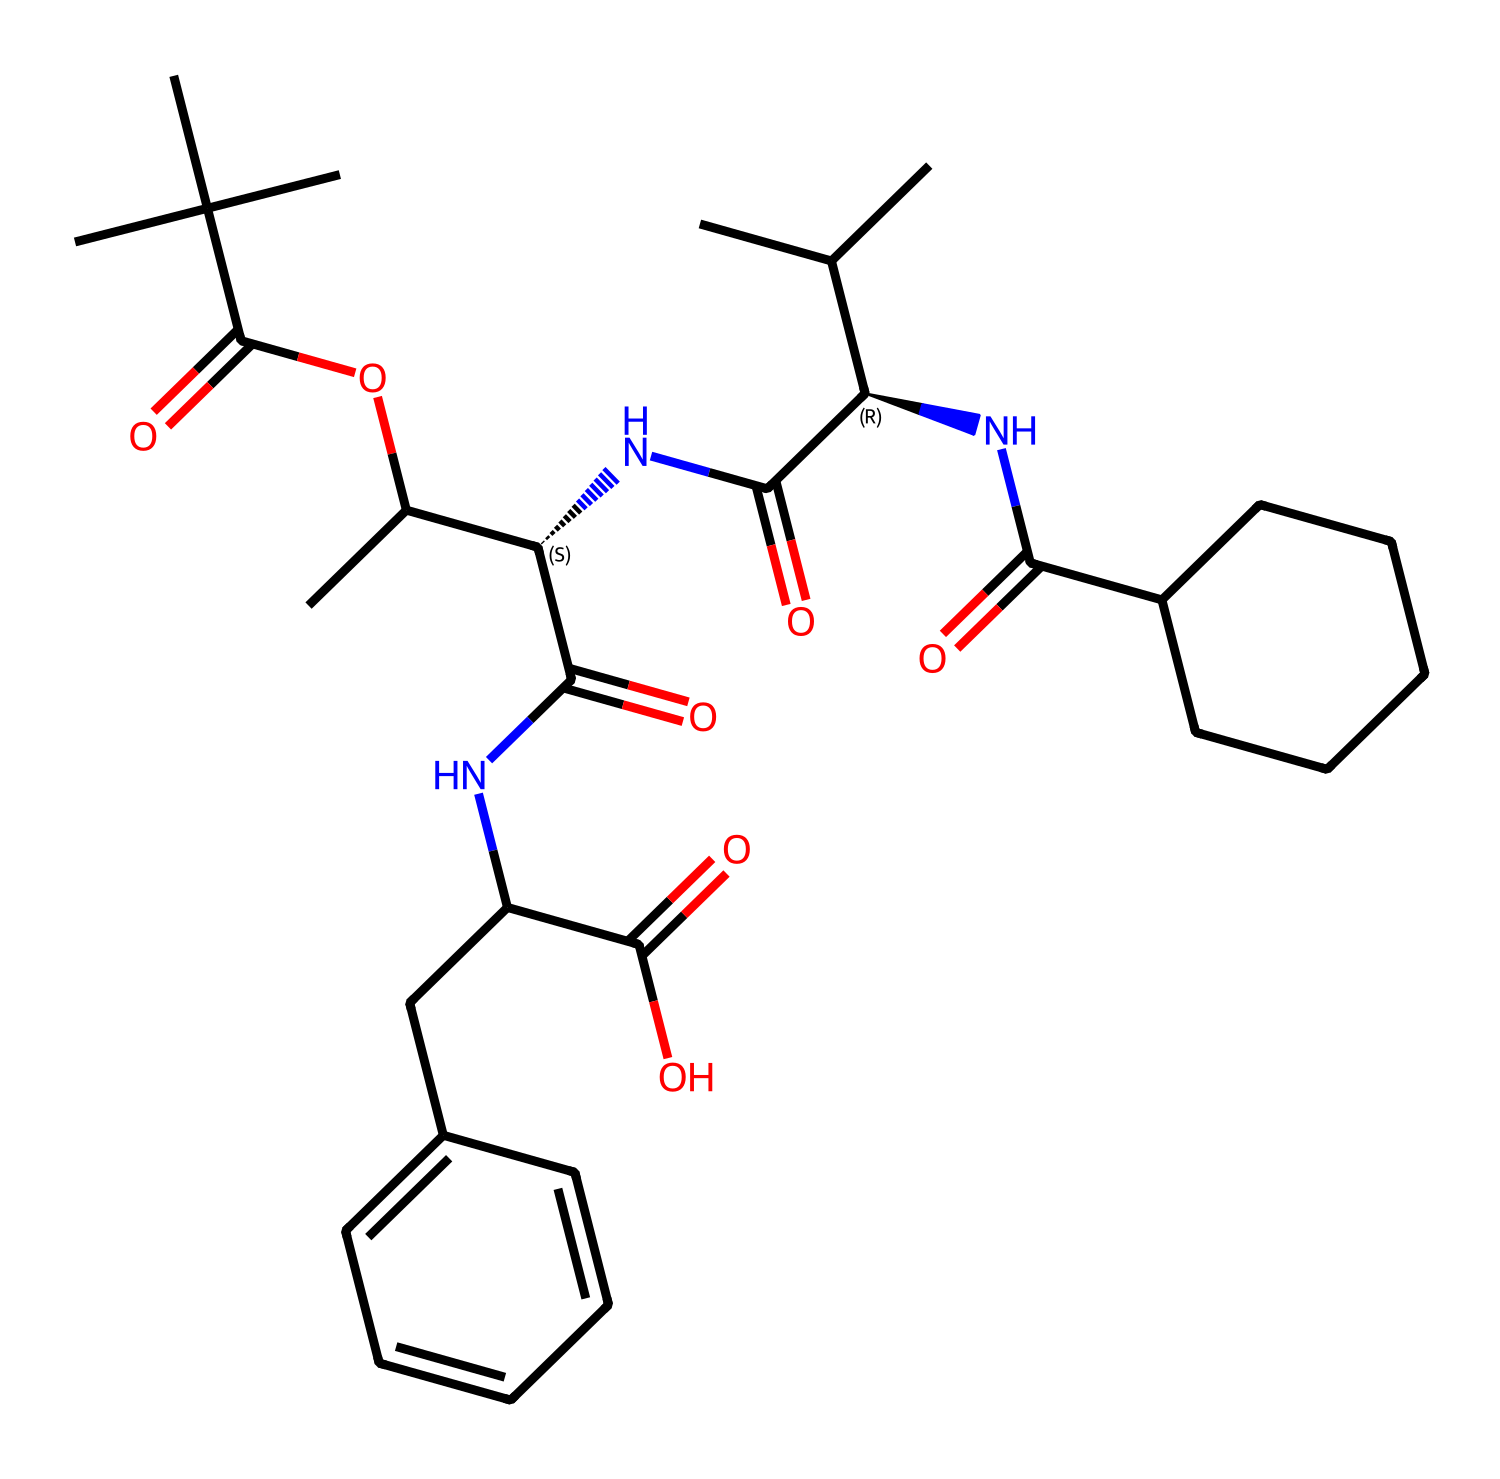What is the total number of carbon atoms in this compound? By examining the SMILES representation, we can count each carbon atom denoted by the 'C' symbol, including those in functional groups. There are 24 carbon atoms in total.
Answer: 24 How many chiral centers are present in this chemical? The symbols '[C@H]' indicate chiral centers in the molecule. By counting each instance of '@' in the structure, we find there are 3 chiral centers present.
Answer: 3 What type of functional groups are present in this molecular structure? Analyzing the SMILES representation reveals multiple functional groups such as esters (C(=O)O), amides (NC(=O)), and carboxylic acids (C(=O)O). Thus, it contains esters, amides, and carboxylic acids.
Answer: esters, amides, carboxylic acids What is the significance of chirality in this compound for its application in geothermal piping? Chirality can influence the mechanical properties and resistance to corrosion of materials. In geothermal piping applications, the enhanced stress distribution due to chiral configurations may lead to improved durability.
Answer: enhanced durability How does the presence of nitrogen affect the overall properties of this compound? Nitrogen in the amine and amide functional groups can enhance the compound's solubility and may increase its resistance to thermal degradation, which is critical for geothermal applications where high temperatures are present.
Answer: increased resistance What role do the aromatic rings play in the stability of this compound? The presence of aromatic rings contributes to the overall stability through resonance, which can help distribute stress across the structure. This stability is important for materials exposed to aggressive geothermal conditions.
Answer: contributes to stability 